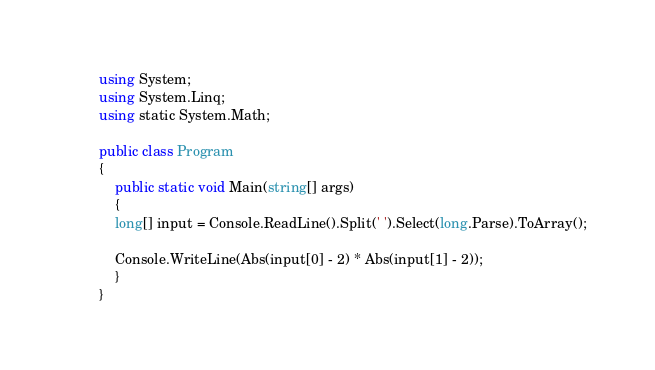<code> <loc_0><loc_0><loc_500><loc_500><_C#_>        using System;
        using System.Linq;
        using static System.Math;

        public class Program
        {
            public static void Main(string[] args)
            {
            long[] input = Console.ReadLine().Split(' ').Select(long.Parse).ToArray();

            Console.WriteLine(Abs(input[0] - 2) * Abs(input[1] - 2));
            }
        }</code> 